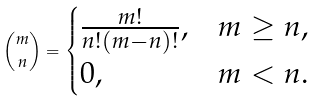<formula> <loc_0><loc_0><loc_500><loc_500>\binom { m } { n } = \begin{cases} \frac { m ! } { n ! ( m - n ) ! } , & m \geq n , \\ 0 , & m < n . \end{cases}</formula> 